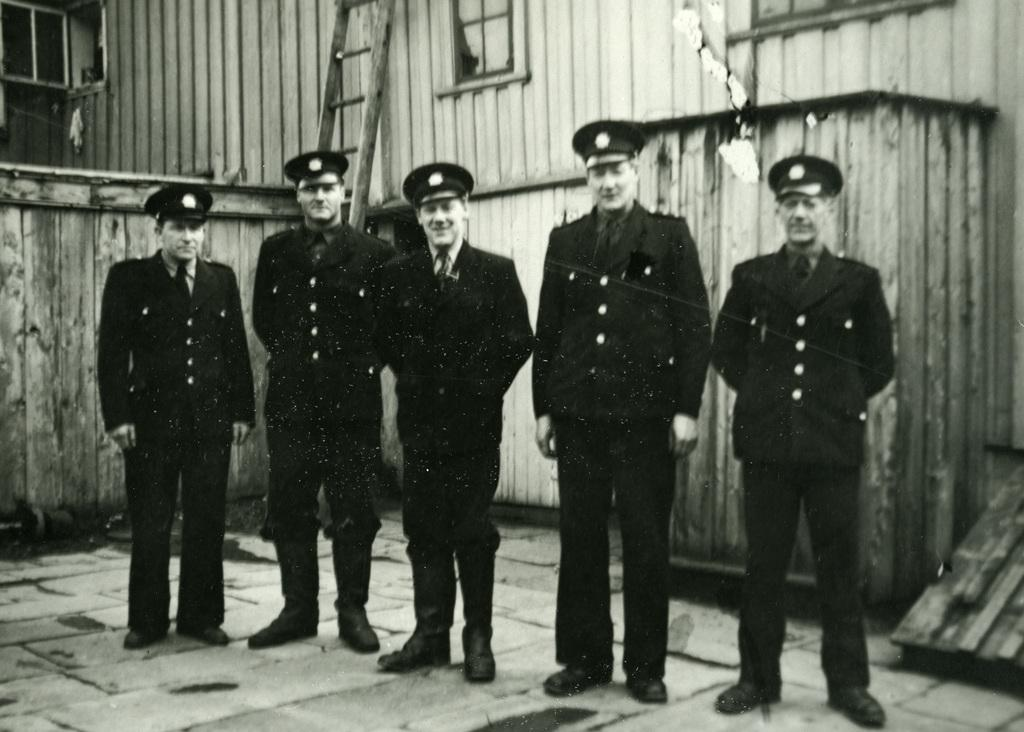What is the color scheme of the image? The image is black and white. How many people can be seen in the image? There are a few people in the image. What is visible beneath the people's feet? There is ground visible in the image. What objects are present on the ground? There are objects on the ground. What is the tall structure in the image? There is a ladder in the image. What is the large, flat surface in the image? There is a wall in the image. What type of birds can be seen flying near the star in the image? There are no birds or stars present in the image; it is a black and white image with a few people, ground, objects, a ladder, and a wall. 